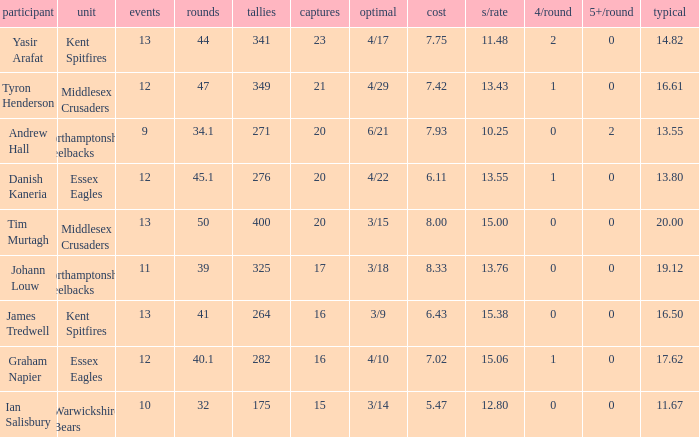Name the matches for wickets 17 11.0. 